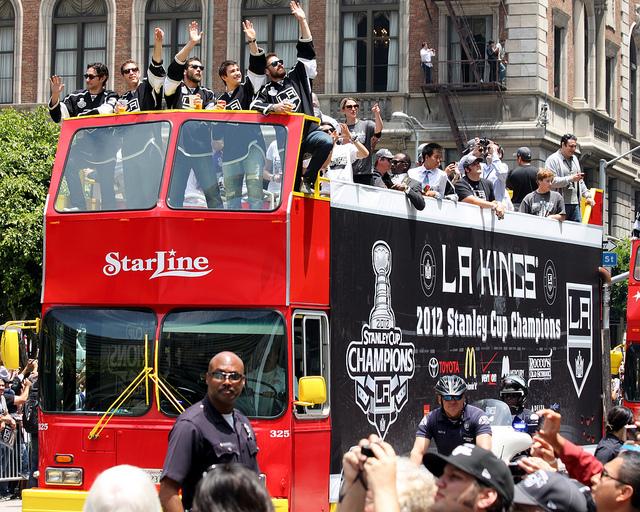Are the people on the top cheering?
Keep it brief. Yes. What is the name of this ice hockey team?
Write a very short answer. La kings. Is this a parade?
Keep it brief. Yes. Is the bus empty?
Write a very short answer. No. 